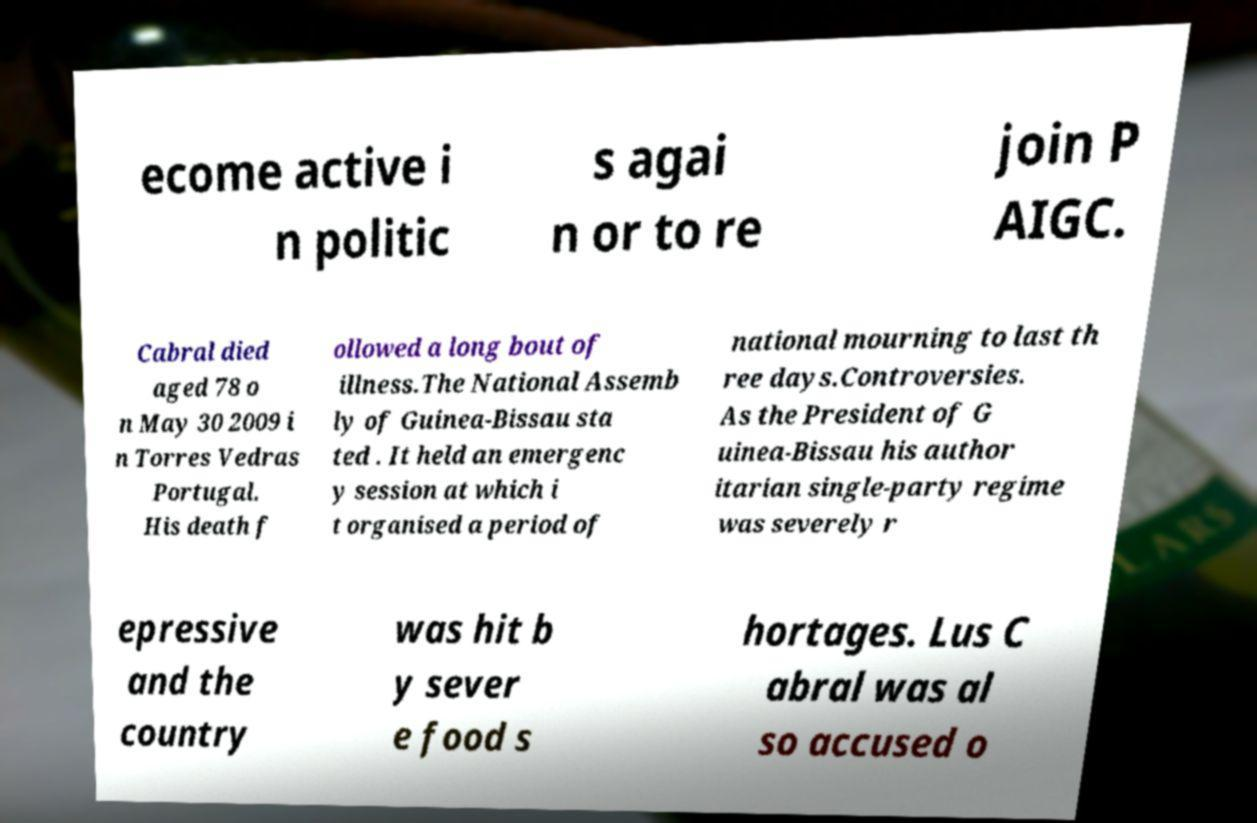I need the written content from this picture converted into text. Can you do that? ecome active i n politic s agai n or to re join P AIGC. Cabral died aged 78 o n May 30 2009 i n Torres Vedras Portugal. His death f ollowed a long bout of illness.The National Assemb ly of Guinea-Bissau sta ted . It held an emergenc y session at which i t organised a period of national mourning to last th ree days.Controversies. As the President of G uinea-Bissau his author itarian single-party regime was severely r epressive and the country was hit b y sever e food s hortages. Lus C abral was al so accused o 